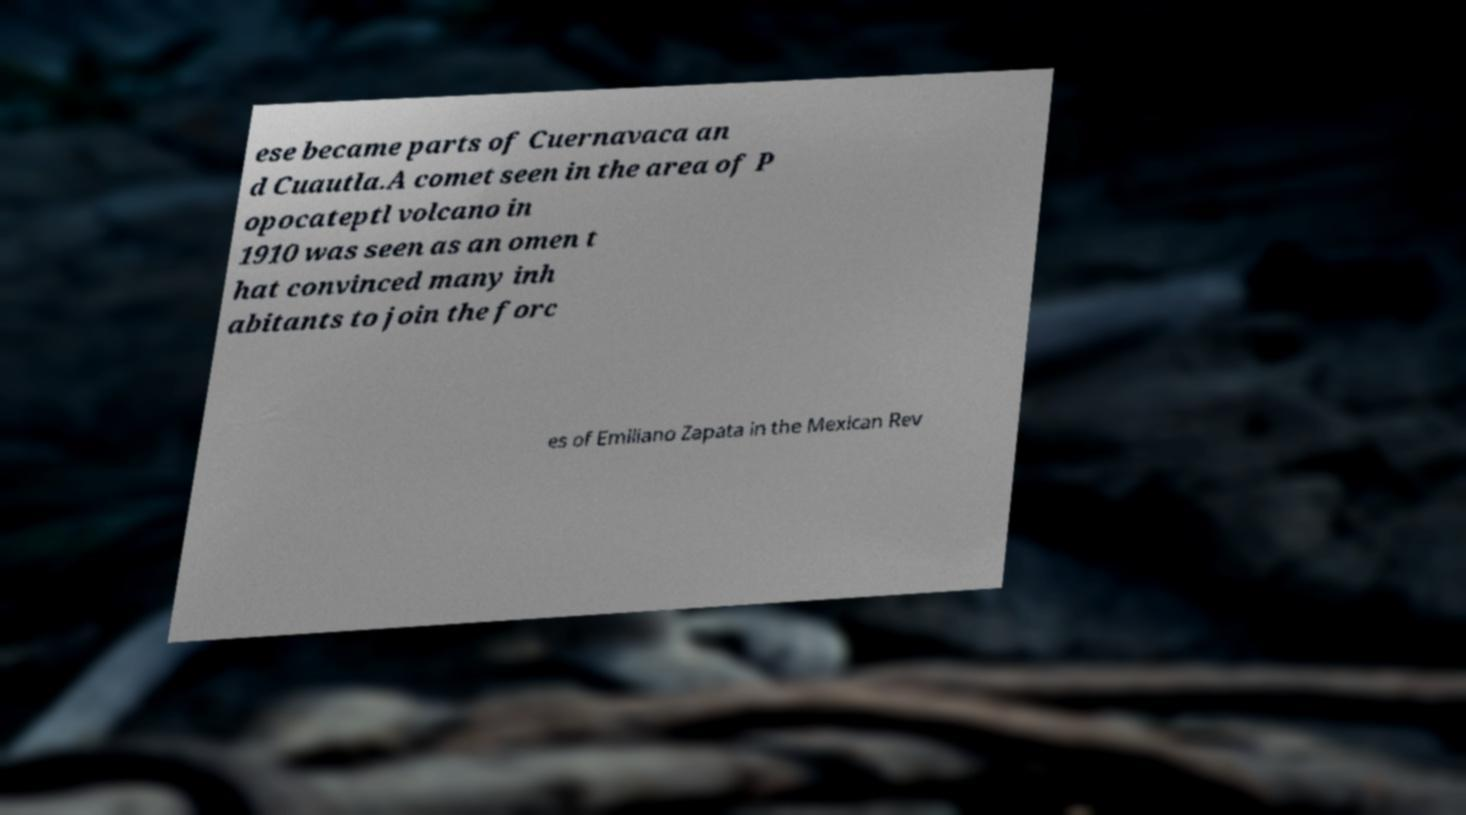Could you extract and type out the text from this image? ese became parts of Cuernavaca an d Cuautla.A comet seen in the area of P opocateptl volcano in 1910 was seen as an omen t hat convinced many inh abitants to join the forc es of Emiliano Zapata in the Mexican Rev 